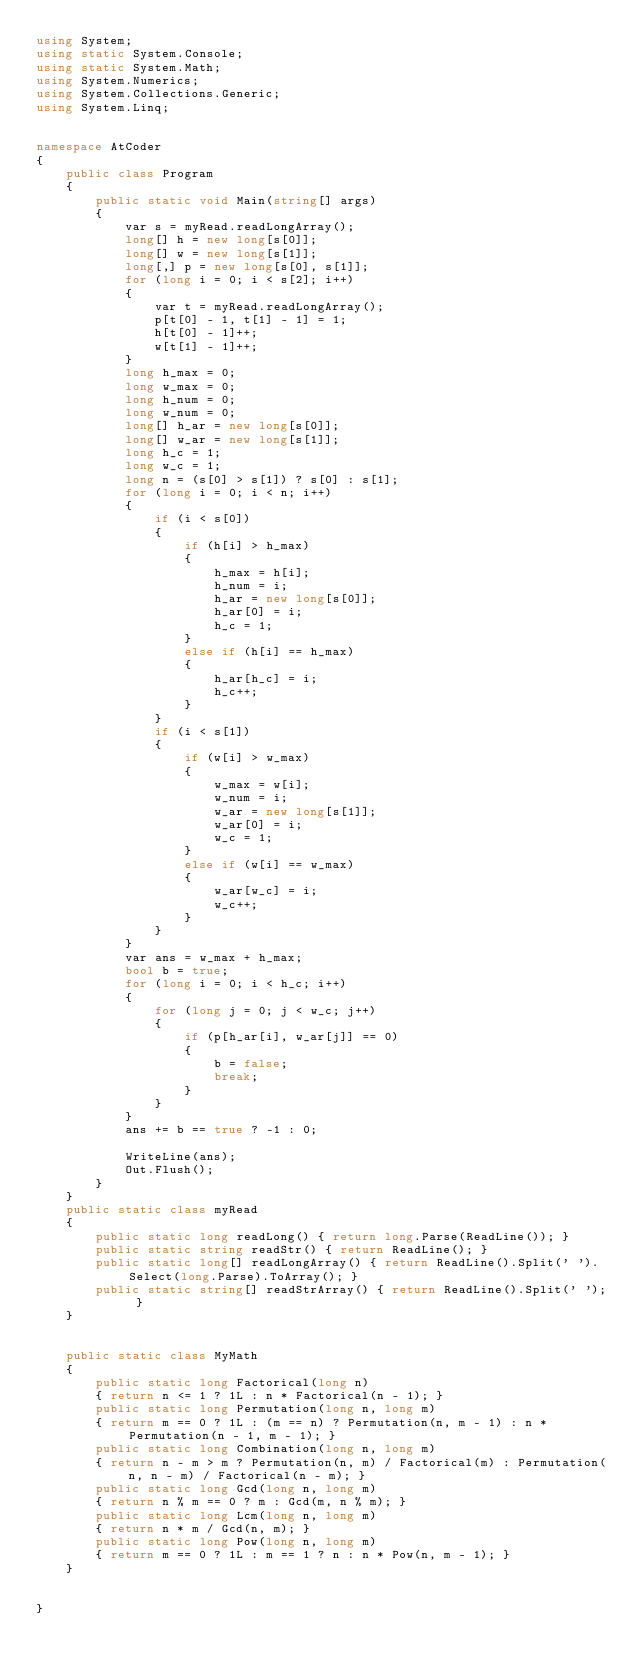<code> <loc_0><loc_0><loc_500><loc_500><_C#_>using System;
using static System.Console;
using static System.Math;
using System.Numerics;
using System.Collections.Generic;
using System.Linq;


namespace AtCoder
{
    public class Program
    {
        public static void Main(string[] args)
        {
            var s = myRead.readLongArray();
            long[] h = new long[s[0]];
            long[] w = new long[s[1]];
            long[,] p = new long[s[0], s[1]];
            for (long i = 0; i < s[2]; i++)
            {
                var t = myRead.readLongArray();
                p[t[0] - 1, t[1] - 1] = 1;
                h[t[0] - 1]++;
                w[t[1] - 1]++;
            }
            long h_max = 0;
            long w_max = 0;
            long h_num = 0;
            long w_num = 0;
            long[] h_ar = new long[s[0]];
            long[] w_ar = new long[s[1]];
            long h_c = 1;
            long w_c = 1;
            long n = (s[0] > s[1]) ? s[0] : s[1];
            for (long i = 0; i < n; i++)
            {
                if (i < s[0])
                {
                    if (h[i] > h_max)
                    {
                        h_max = h[i];
                        h_num = i;
                        h_ar = new long[s[0]];
                        h_ar[0] = i;
                        h_c = 1;
                    }
                    else if (h[i] == h_max)
                    {
                        h_ar[h_c] = i;
                        h_c++;
                    }
                }
                if (i < s[1])
                {
                    if (w[i] > w_max)
                    {
                        w_max = w[i];
                        w_num = i;
                        w_ar = new long[s[1]];
                        w_ar[0] = i;
                        w_c = 1;
                    }
                    else if (w[i] == w_max)
                    {
                        w_ar[w_c] = i;
                        w_c++;
                    }
                }
            }
            var ans = w_max + h_max;
            bool b = true;
            for (long i = 0; i < h_c; i++)
            {
                for (long j = 0; j < w_c; j++)
                {
                    if (p[h_ar[i], w_ar[j]] == 0)
                    {
                        b = false;
                        break;
                    }
                }
            }
            ans += b == true ? -1 : 0;

            WriteLine(ans);
            Out.Flush();
        }
    }
    public static class myRead
    {
        public static long readLong() { return long.Parse(ReadLine()); }
        public static string readStr() { return ReadLine(); }
        public static long[] readLongArray() { return ReadLine().Split(' ').Select(long.Parse).ToArray(); }
        public static string[] readStrArray() { return ReadLine().Split(' '); }
    }


    public static class MyMath
    {
        public static long Factorical(long n)
        { return n <= 1 ? 1L : n * Factorical(n - 1); }
        public static long Permutation(long n, long m)
        { return m == 0 ? 1L : (m == n) ? Permutation(n, m - 1) : n * Permutation(n - 1, m - 1); }
        public static long Combination(long n, long m)
        { return n - m > m ? Permutation(n, m) / Factorical(m) : Permutation(n, n - m) / Factorical(n - m); }
        public static long Gcd(long n, long m)
        { return n % m == 0 ? m : Gcd(m, n % m); }
        public static long Lcm(long n, long m)
        { return n * m / Gcd(n, m); }
        public static long Pow(long n, long m)
        { return m == 0 ? 1L : m == 1 ? n : n * Pow(n, m - 1); }
    }


}</code> 